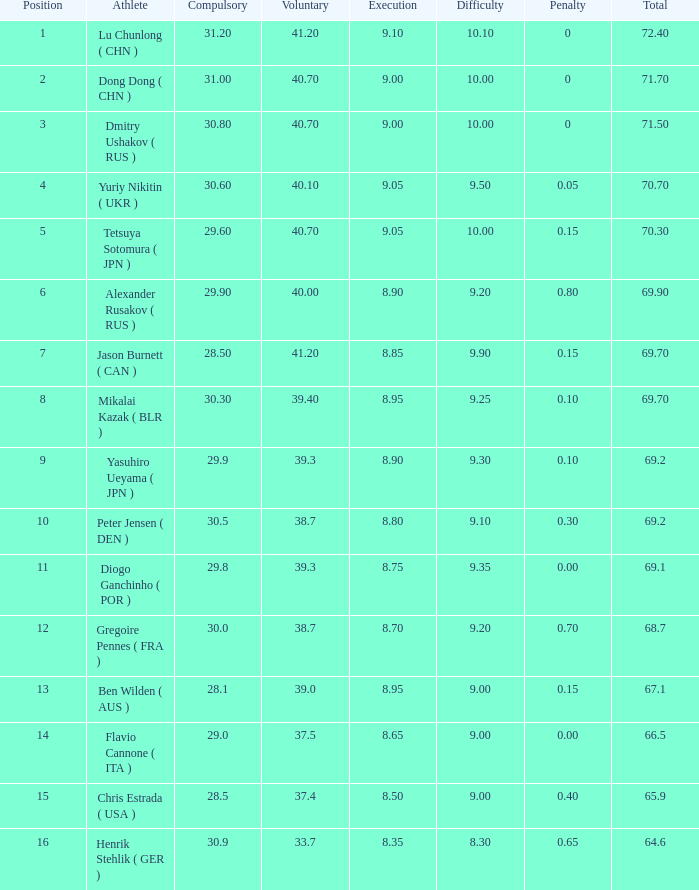What's the total compulsory when the total is more than 69.2 and the voluntary is 38.7? 0.0. 